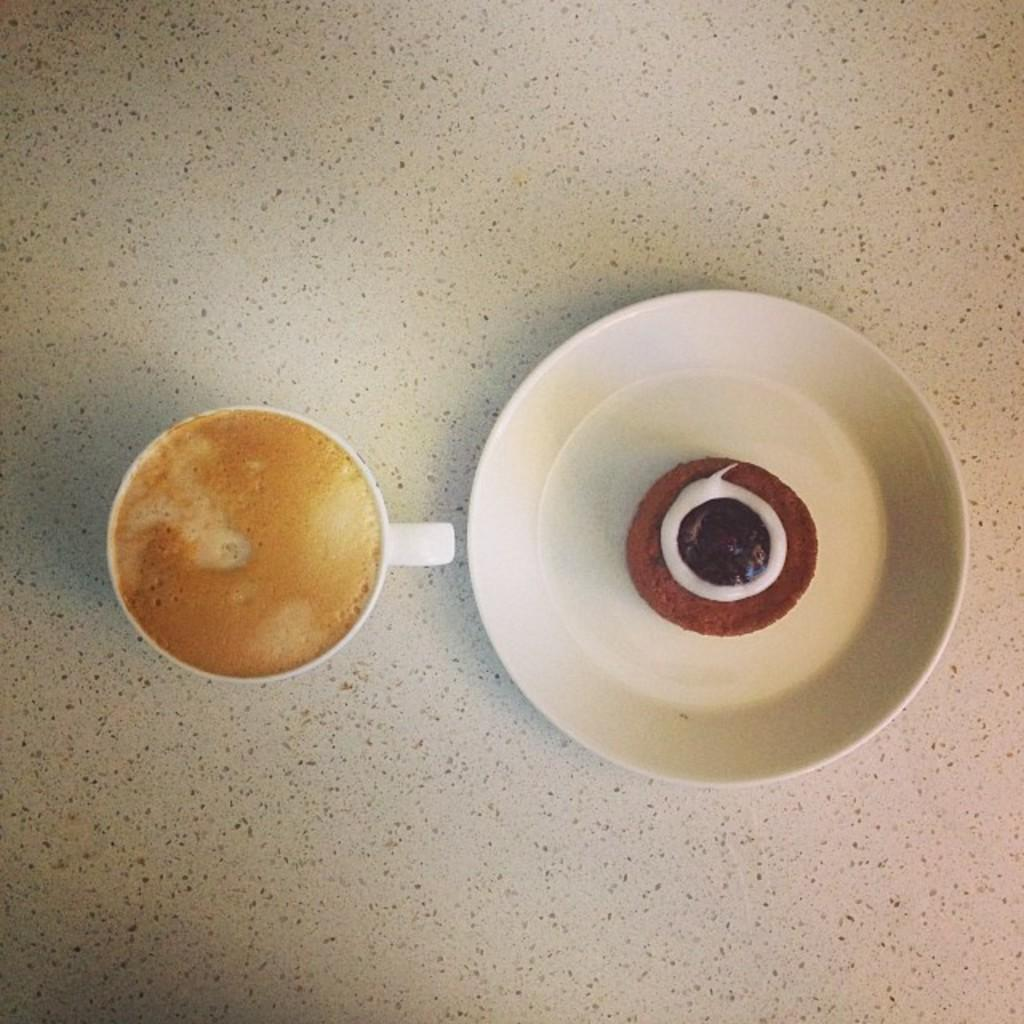What is in the cup that is visible in the image? There is a cup containing coffee in the image. What is on the plate that is visible in the image? There is a plate containing a cupcake in the image. Where might the cup and plate be placed in the image? The background of the image might be a table. What color is the background of the image? The background of the image is white in color. How many ladybugs can be seen crawling on the cupcake in the image? There are no ladybugs present in the image; it only features a cup of coffee and a cupcake. 